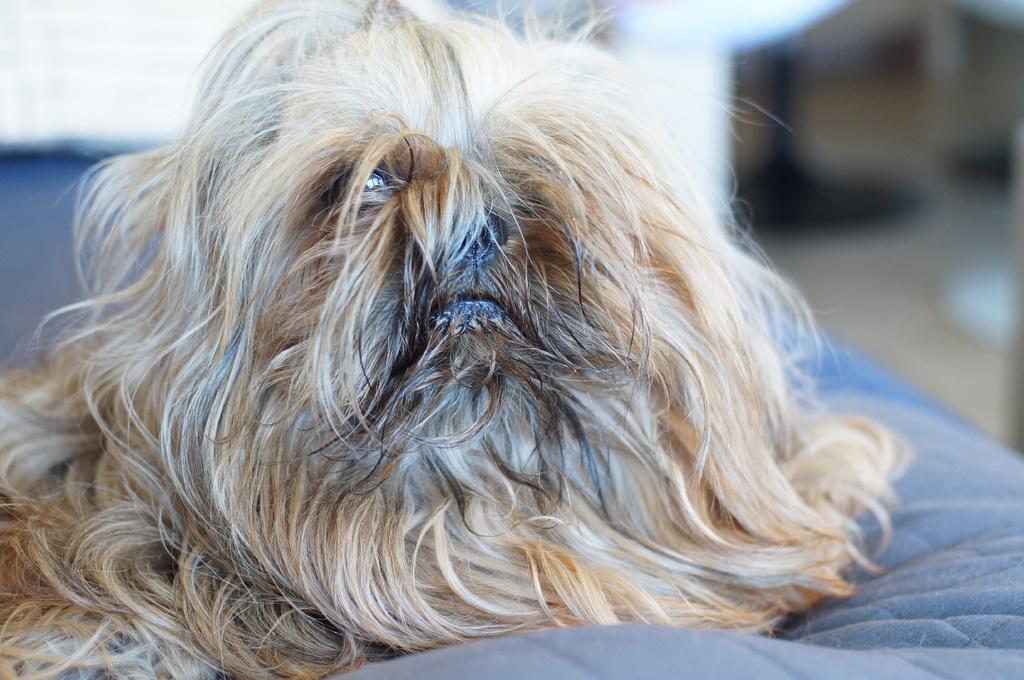Please provide a concise description of this image. In this image in the foreground and there is one dog, and at the bottom there is bed and there is a blurry background. 